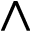<formula> <loc_0><loc_0><loc_500><loc_500>\wedge</formula> 